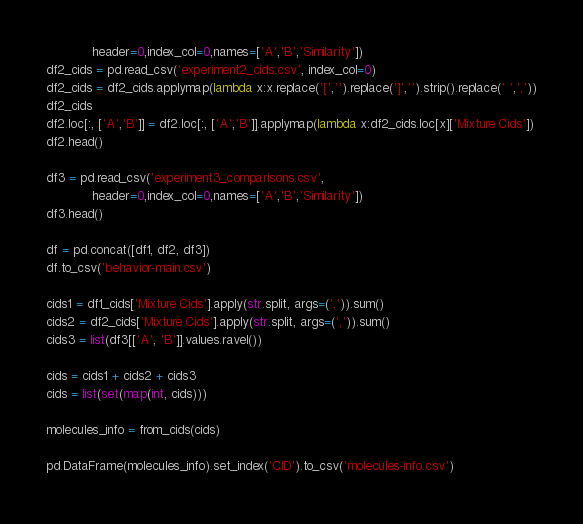Convert code to text. <code><loc_0><loc_0><loc_500><loc_500><_Python_>            header=0,index_col=0,names=['A','B','Similarity'])
df2_cids = pd.read_csv('experiment2_cids.csv', index_col=0)
df2_cids = df2_cids.applymap(lambda x:x.replace('[','').replace(']','').strip().replace(' ',','))
df2_cids
df2.loc[:, ['A','B']] = df2.loc[:, ['A','B']].applymap(lambda x:df2_cids.loc[x]['Mixture Cids'])
df2.head()

df3 = pd.read_csv('experiment3_comparisons.csv',
            header=0,index_col=0,names=['A','B','Similarity'])
df3.head()

df = pd.concat([df1, df2, df3])
df.to_csv('behavior-main.csv')

cids1 = df1_cids['Mixture Cids'].apply(str.split, args=(',')).sum()
cids2 = df2_cids['Mixture Cids'].apply(str.split, args=(',')).sum()
cids3 = list(df3[['A', 'B']].values.ravel())

cids = cids1 + cids2 + cids3
cids = list(set(map(int, cids)))

molecules_info = from_cids(cids)

pd.DataFrame(molecules_info).set_index('CID').to_csv('molecules-info.csv')
</code> 